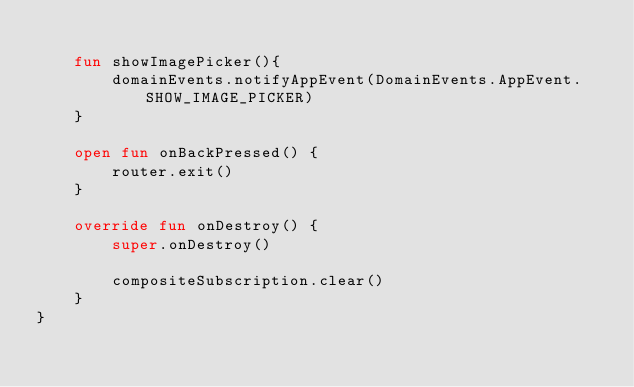Convert code to text. <code><loc_0><loc_0><loc_500><loc_500><_Kotlin_>
    fun showImagePicker(){
        domainEvents.notifyAppEvent(DomainEvents.AppEvent.SHOW_IMAGE_PICKER)
    }

    open fun onBackPressed() {
        router.exit()
    }

    override fun onDestroy() {
        super.onDestroy()

        compositeSubscription.clear()
    }
}</code> 